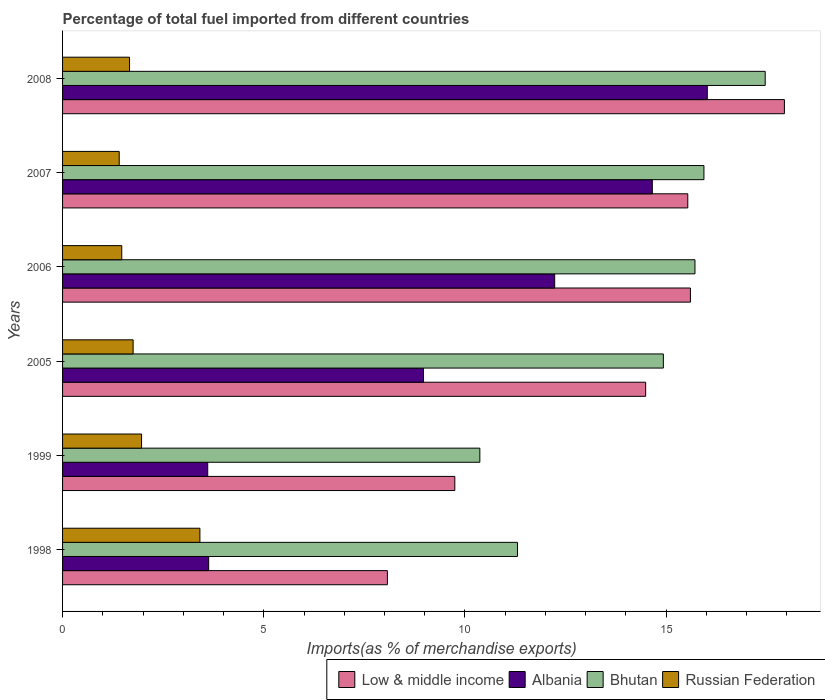How many different coloured bars are there?
Your response must be concise. 4. Are the number of bars per tick equal to the number of legend labels?
Ensure brevity in your answer.  Yes. How many bars are there on the 4th tick from the top?
Keep it short and to the point. 4. In how many cases, is the number of bars for a given year not equal to the number of legend labels?
Make the answer very short. 0. What is the percentage of imports to different countries in Russian Federation in 2005?
Keep it short and to the point. 1.75. Across all years, what is the maximum percentage of imports to different countries in Russian Federation?
Keep it short and to the point. 3.41. Across all years, what is the minimum percentage of imports to different countries in Low & middle income?
Offer a very short reply. 8.07. In which year was the percentage of imports to different countries in Albania minimum?
Your answer should be very brief. 1999. What is the total percentage of imports to different countries in Low & middle income in the graph?
Keep it short and to the point. 81.38. What is the difference between the percentage of imports to different countries in Russian Federation in 2007 and that in 2008?
Make the answer very short. -0.26. What is the difference between the percentage of imports to different countries in Russian Federation in 2006 and the percentage of imports to different countries in Albania in 2005?
Provide a succinct answer. -7.5. What is the average percentage of imports to different countries in Low & middle income per year?
Provide a short and direct response. 13.56. In the year 2006, what is the difference between the percentage of imports to different countries in Bhutan and percentage of imports to different countries in Albania?
Keep it short and to the point. 3.49. What is the ratio of the percentage of imports to different countries in Albania in 1999 to that in 2006?
Give a very brief answer. 0.29. Is the difference between the percentage of imports to different countries in Bhutan in 2005 and 2007 greater than the difference between the percentage of imports to different countries in Albania in 2005 and 2007?
Offer a very short reply. Yes. What is the difference between the highest and the second highest percentage of imports to different countries in Albania?
Provide a succinct answer. 1.37. What is the difference between the highest and the lowest percentage of imports to different countries in Low & middle income?
Your answer should be very brief. 9.87. In how many years, is the percentage of imports to different countries in Bhutan greater than the average percentage of imports to different countries in Bhutan taken over all years?
Offer a very short reply. 4. Is the sum of the percentage of imports to different countries in Bhutan in 1999 and 2006 greater than the maximum percentage of imports to different countries in Russian Federation across all years?
Make the answer very short. Yes. What does the 4th bar from the top in 2007 represents?
Ensure brevity in your answer.  Low & middle income. What does the 3rd bar from the bottom in 2005 represents?
Give a very brief answer. Bhutan. Is it the case that in every year, the sum of the percentage of imports to different countries in Bhutan and percentage of imports to different countries in Low & middle income is greater than the percentage of imports to different countries in Russian Federation?
Your answer should be compact. Yes. How many bars are there?
Ensure brevity in your answer.  24. Are all the bars in the graph horizontal?
Offer a very short reply. Yes. How many years are there in the graph?
Your response must be concise. 6. Are the values on the major ticks of X-axis written in scientific E-notation?
Ensure brevity in your answer.  No. Does the graph contain any zero values?
Keep it short and to the point. No. Where does the legend appear in the graph?
Provide a succinct answer. Bottom right. How many legend labels are there?
Offer a terse response. 4. What is the title of the graph?
Provide a succinct answer. Percentage of total fuel imported from different countries. What is the label or title of the X-axis?
Ensure brevity in your answer.  Imports(as % of merchandise exports). What is the Imports(as % of merchandise exports) of Low & middle income in 1998?
Offer a very short reply. 8.07. What is the Imports(as % of merchandise exports) of Albania in 1998?
Give a very brief answer. 3.63. What is the Imports(as % of merchandise exports) in Bhutan in 1998?
Your answer should be very brief. 11.3. What is the Imports(as % of merchandise exports) of Russian Federation in 1998?
Give a very brief answer. 3.41. What is the Imports(as % of merchandise exports) of Low & middle income in 1999?
Offer a terse response. 9.75. What is the Imports(as % of merchandise exports) in Albania in 1999?
Offer a very short reply. 3.61. What is the Imports(as % of merchandise exports) of Bhutan in 1999?
Provide a short and direct response. 10.37. What is the Imports(as % of merchandise exports) in Russian Federation in 1999?
Give a very brief answer. 1.96. What is the Imports(as % of merchandise exports) in Low & middle income in 2005?
Your response must be concise. 14.49. What is the Imports(as % of merchandise exports) in Albania in 2005?
Offer a very short reply. 8.97. What is the Imports(as % of merchandise exports) in Bhutan in 2005?
Offer a terse response. 14.93. What is the Imports(as % of merchandise exports) in Russian Federation in 2005?
Offer a very short reply. 1.75. What is the Imports(as % of merchandise exports) in Low & middle income in 2006?
Your answer should be compact. 15.6. What is the Imports(as % of merchandise exports) of Albania in 2006?
Give a very brief answer. 12.23. What is the Imports(as % of merchandise exports) of Bhutan in 2006?
Offer a very short reply. 15.71. What is the Imports(as % of merchandise exports) in Russian Federation in 2006?
Offer a very short reply. 1.47. What is the Imports(as % of merchandise exports) in Low & middle income in 2007?
Give a very brief answer. 15.54. What is the Imports(as % of merchandise exports) of Albania in 2007?
Offer a very short reply. 14.66. What is the Imports(as % of merchandise exports) in Bhutan in 2007?
Your response must be concise. 15.94. What is the Imports(as % of merchandise exports) in Russian Federation in 2007?
Your answer should be very brief. 1.41. What is the Imports(as % of merchandise exports) of Low & middle income in 2008?
Offer a terse response. 17.94. What is the Imports(as % of merchandise exports) of Albania in 2008?
Your response must be concise. 16.02. What is the Imports(as % of merchandise exports) in Bhutan in 2008?
Your answer should be compact. 17.46. What is the Imports(as % of merchandise exports) of Russian Federation in 2008?
Provide a short and direct response. 1.66. Across all years, what is the maximum Imports(as % of merchandise exports) in Low & middle income?
Offer a terse response. 17.94. Across all years, what is the maximum Imports(as % of merchandise exports) in Albania?
Your response must be concise. 16.02. Across all years, what is the maximum Imports(as % of merchandise exports) in Bhutan?
Offer a very short reply. 17.46. Across all years, what is the maximum Imports(as % of merchandise exports) of Russian Federation?
Provide a succinct answer. 3.41. Across all years, what is the minimum Imports(as % of merchandise exports) in Low & middle income?
Offer a very short reply. 8.07. Across all years, what is the minimum Imports(as % of merchandise exports) of Albania?
Keep it short and to the point. 3.61. Across all years, what is the minimum Imports(as % of merchandise exports) of Bhutan?
Offer a very short reply. 10.37. Across all years, what is the minimum Imports(as % of merchandise exports) in Russian Federation?
Ensure brevity in your answer.  1.41. What is the total Imports(as % of merchandise exports) in Low & middle income in the graph?
Make the answer very short. 81.38. What is the total Imports(as % of merchandise exports) of Albania in the graph?
Offer a very short reply. 59.11. What is the total Imports(as % of merchandise exports) in Bhutan in the graph?
Offer a very short reply. 85.72. What is the total Imports(as % of merchandise exports) in Russian Federation in the graph?
Provide a short and direct response. 11.67. What is the difference between the Imports(as % of merchandise exports) of Low & middle income in 1998 and that in 1999?
Ensure brevity in your answer.  -1.68. What is the difference between the Imports(as % of merchandise exports) of Albania in 1998 and that in 1999?
Provide a succinct answer. 0.02. What is the difference between the Imports(as % of merchandise exports) in Bhutan in 1998 and that in 1999?
Your answer should be very brief. 0.94. What is the difference between the Imports(as % of merchandise exports) in Russian Federation in 1998 and that in 1999?
Ensure brevity in your answer.  1.45. What is the difference between the Imports(as % of merchandise exports) of Low & middle income in 1998 and that in 2005?
Offer a terse response. -6.42. What is the difference between the Imports(as % of merchandise exports) in Albania in 1998 and that in 2005?
Ensure brevity in your answer.  -5.34. What is the difference between the Imports(as % of merchandise exports) in Bhutan in 1998 and that in 2005?
Offer a very short reply. -3.62. What is the difference between the Imports(as % of merchandise exports) of Russian Federation in 1998 and that in 2005?
Make the answer very short. 1.66. What is the difference between the Imports(as % of merchandise exports) of Low & middle income in 1998 and that in 2006?
Make the answer very short. -7.53. What is the difference between the Imports(as % of merchandise exports) in Albania in 1998 and that in 2006?
Provide a short and direct response. -8.6. What is the difference between the Imports(as % of merchandise exports) of Bhutan in 1998 and that in 2006?
Offer a terse response. -4.41. What is the difference between the Imports(as % of merchandise exports) in Russian Federation in 1998 and that in 2006?
Provide a short and direct response. 1.94. What is the difference between the Imports(as % of merchandise exports) of Low & middle income in 1998 and that in 2007?
Offer a terse response. -7.46. What is the difference between the Imports(as % of merchandise exports) in Albania in 1998 and that in 2007?
Offer a terse response. -11.02. What is the difference between the Imports(as % of merchandise exports) in Bhutan in 1998 and that in 2007?
Provide a succinct answer. -4.63. What is the difference between the Imports(as % of merchandise exports) of Russian Federation in 1998 and that in 2007?
Your answer should be compact. 2. What is the difference between the Imports(as % of merchandise exports) of Low & middle income in 1998 and that in 2008?
Provide a short and direct response. -9.87. What is the difference between the Imports(as % of merchandise exports) of Albania in 1998 and that in 2008?
Provide a short and direct response. -12.39. What is the difference between the Imports(as % of merchandise exports) in Bhutan in 1998 and that in 2008?
Provide a short and direct response. -6.16. What is the difference between the Imports(as % of merchandise exports) in Russian Federation in 1998 and that in 2008?
Your response must be concise. 1.75. What is the difference between the Imports(as % of merchandise exports) in Low & middle income in 1999 and that in 2005?
Your response must be concise. -4.74. What is the difference between the Imports(as % of merchandise exports) in Albania in 1999 and that in 2005?
Keep it short and to the point. -5.36. What is the difference between the Imports(as % of merchandise exports) of Bhutan in 1999 and that in 2005?
Your answer should be very brief. -4.56. What is the difference between the Imports(as % of merchandise exports) in Russian Federation in 1999 and that in 2005?
Offer a terse response. 0.21. What is the difference between the Imports(as % of merchandise exports) in Low & middle income in 1999 and that in 2006?
Your response must be concise. -5.85. What is the difference between the Imports(as % of merchandise exports) of Albania in 1999 and that in 2006?
Offer a terse response. -8.62. What is the difference between the Imports(as % of merchandise exports) in Bhutan in 1999 and that in 2006?
Provide a succinct answer. -5.35. What is the difference between the Imports(as % of merchandise exports) of Russian Federation in 1999 and that in 2006?
Give a very brief answer. 0.49. What is the difference between the Imports(as % of merchandise exports) of Low & middle income in 1999 and that in 2007?
Provide a short and direct response. -5.79. What is the difference between the Imports(as % of merchandise exports) in Albania in 1999 and that in 2007?
Your answer should be compact. -11.05. What is the difference between the Imports(as % of merchandise exports) of Bhutan in 1999 and that in 2007?
Offer a terse response. -5.57. What is the difference between the Imports(as % of merchandise exports) in Russian Federation in 1999 and that in 2007?
Offer a terse response. 0.56. What is the difference between the Imports(as % of merchandise exports) in Low & middle income in 1999 and that in 2008?
Offer a very short reply. -8.19. What is the difference between the Imports(as % of merchandise exports) of Albania in 1999 and that in 2008?
Give a very brief answer. -12.41. What is the difference between the Imports(as % of merchandise exports) in Bhutan in 1999 and that in 2008?
Provide a short and direct response. -7.09. What is the difference between the Imports(as % of merchandise exports) of Russian Federation in 1999 and that in 2008?
Make the answer very short. 0.3. What is the difference between the Imports(as % of merchandise exports) of Low & middle income in 2005 and that in 2006?
Give a very brief answer. -1.11. What is the difference between the Imports(as % of merchandise exports) of Albania in 2005 and that in 2006?
Keep it short and to the point. -3.26. What is the difference between the Imports(as % of merchandise exports) of Bhutan in 2005 and that in 2006?
Ensure brevity in your answer.  -0.79. What is the difference between the Imports(as % of merchandise exports) of Russian Federation in 2005 and that in 2006?
Make the answer very short. 0.28. What is the difference between the Imports(as % of merchandise exports) in Low & middle income in 2005 and that in 2007?
Make the answer very short. -1.05. What is the difference between the Imports(as % of merchandise exports) in Albania in 2005 and that in 2007?
Keep it short and to the point. -5.69. What is the difference between the Imports(as % of merchandise exports) in Bhutan in 2005 and that in 2007?
Offer a terse response. -1.01. What is the difference between the Imports(as % of merchandise exports) of Russian Federation in 2005 and that in 2007?
Provide a succinct answer. 0.35. What is the difference between the Imports(as % of merchandise exports) in Low & middle income in 2005 and that in 2008?
Provide a short and direct response. -3.45. What is the difference between the Imports(as % of merchandise exports) in Albania in 2005 and that in 2008?
Make the answer very short. -7.05. What is the difference between the Imports(as % of merchandise exports) in Bhutan in 2005 and that in 2008?
Keep it short and to the point. -2.53. What is the difference between the Imports(as % of merchandise exports) in Russian Federation in 2005 and that in 2008?
Your response must be concise. 0.09. What is the difference between the Imports(as % of merchandise exports) in Low & middle income in 2006 and that in 2007?
Keep it short and to the point. 0.07. What is the difference between the Imports(as % of merchandise exports) of Albania in 2006 and that in 2007?
Give a very brief answer. -2.43. What is the difference between the Imports(as % of merchandise exports) in Bhutan in 2006 and that in 2007?
Your response must be concise. -0.22. What is the difference between the Imports(as % of merchandise exports) in Russian Federation in 2006 and that in 2007?
Make the answer very short. 0.06. What is the difference between the Imports(as % of merchandise exports) of Low & middle income in 2006 and that in 2008?
Offer a very short reply. -2.34. What is the difference between the Imports(as % of merchandise exports) in Albania in 2006 and that in 2008?
Your answer should be compact. -3.79. What is the difference between the Imports(as % of merchandise exports) in Bhutan in 2006 and that in 2008?
Provide a short and direct response. -1.75. What is the difference between the Imports(as % of merchandise exports) in Russian Federation in 2006 and that in 2008?
Ensure brevity in your answer.  -0.19. What is the difference between the Imports(as % of merchandise exports) in Low & middle income in 2007 and that in 2008?
Offer a very short reply. -2.4. What is the difference between the Imports(as % of merchandise exports) of Albania in 2007 and that in 2008?
Give a very brief answer. -1.37. What is the difference between the Imports(as % of merchandise exports) in Bhutan in 2007 and that in 2008?
Give a very brief answer. -1.52. What is the difference between the Imports(as % of merchandise exports) of Russian Federation in 2007 and that in 2008?
Your response must be concise. -0.26. What is the difference between the Imports(as % of merchandise exports) of Low & middle income in 1998 and the Imports(as % of merchandise exports) of Albania in 1999?
Keep it short and to the point. 4.46. What is the difference between the Imports(as % of merchandise exports) of Low & middle income in 1998 and the Imports(as % of merchandise exports) of Bhutan in 1999?
Offer a very short reply. -2.3. What is the difference between the Imports(as % of merchandise exports) in Low & middle income in 1998 and the Imports(as % of merchandise exports) in Russian Federation in 1999?
Ensure brevity in your answer.  6.11. What is the difference between the Imports(as % of merchandise exports) in Albania in 1998 and the Imports(as % of merchandise exports) in Bhutan in 1999?
Provide a succinct answer. -6.74. What is the difference between the Imports(as % of merchandise exports) in Albania in 1998 and the Imports(as % of merchandise exports) in Russian Federation in 1999?
Keep it short and to the point. 1.67. What is the difference between the Imports(as % of merchandise exports) in Bhutan in 1998 and the Imports(as % of merchandise exports) in Russian Federation in 1999?
Offer a very short reply. 9.34. What is the difference between the Imports(as % of merchandise exports) of Low & middle income in 1998 and the Imports(as % of merchandise exports) of Albania in 2005?
Give a very brief answer. -0.9. What is the difference between the Imports(as % of merchandise exports) in Low & middle income in 1998 and the Imports(as % of merchandise exports) in Bhutan in 2005?
Ensure brevity in your answer.  -6.86. What is the difference between the Imports(as % of merchandise exports) in Low & middle income in 1998 and the Imports(as % of merchandise exports) in Russian Federation in 2005?
Keep it short and to the point. 6.32. What is the difference between the Imports(as % of merchandise exports) of Albania in 1998 and the Imports(as % of merchandise exports) of Bhutan in 2005?
Provide a short and direct response. -11.3. What is the difference between the Imports(as % of merchandise exports) of Albania in 1998 and the Imports(as % of merchandise exports) of Russian Federation in 2005?
Your answer should be compact. 1.88. What is the difference between the Imports(as % of merchandise exports) in Bhutan in 1998 and the Imports(as % of merchandise exports) in Russian Federation in 2005?
Ensure brevity in your answer.  9.55. What is the difference between the Imports(as % of merchandise exports) of Low & middle income in 1998 and the Imports(as % of merchandise exports) of Albania in 2006?
Give a very brief answer. -4.16. What is the difference between the Imports(as % of merchandise exports) of Low & middle income in 1998 and the Imports(as % of merchandise exports) of Bhutan in 2006?
Make the answer very short. -7.64. What is the difference between the Imports(as % of merchandise exports) in Low & middle income in 1998 and the Imports(as % of merchandise exports) in Russian Federation in 2006?
Offer a terse response. 6.6. What is the difference between the Imports(as % of merchandise exports) of Albania in 1998 and the Imports(as % of merchandise exports) of Bhutan in 2006?
Offer a very short reply. -12.08. What is the difference between the Imports(as % of merchandise exports) of Albania in 1998 and the Imports(as % of merchandise exports) of Russian Federation in 2006?
Offer a very short reply. 2.16. What is the difference between the Imports(as % of merchandise exports) in Bhutan in 1998 and the Imports(as % of merchandise exports) in Russian Federation in 2006?
Your answer should be very brief. 9.83. What is the difference between the Imports(as % of merchandise exports) in Low & middle income in 1998 and the Imports(as % of merchandise exports) in Albania in 2007?
Ensure brevity in your answer.  -6.58. What is the difference between the Imports(as % of merchandise exports) of Low & middle income in 1998 and the Imports(as % of merchandise exports) of Bhutan in 2007?
Ensure brevity in your answer.  -7.87. What is the difference between the Imports(as % of merchandise exports) in Low & middle income in 1998 and the Imports(as % of merchandise exports) in Russian Federation in 2007?
Keep it short and to the point. 6.66. What is the difference between the Imports(as % of merchandise exports) of Albania in 1998 and the Imports(as % of merchandise exports) of Bhutan in 2007?
Give a very brief answer. -12.31. What is the difference between the Imports(as % of merchandise exports) of Albania in 1998 and the Imports(as % of merchandise exports) of Russian Federation in 2007?
Keep it short and to the point. 2.22. What is the difference between the Imports(as % of merchandise exports) in Bhutan in 1998 and the Imports(as % of merchandise exports) in Russian Federation in 2007?
Offer a very short reply. 9.9. What is the difference between the Imports(as % of merchandise exports) of Low & middle income in 1998 and the Imports(as % of merchandise exports) of Albania in 2008?
Provide a succinct answer. -7.95. What is the difference between the Imports(as % of merchandise exports) of Low & middle income in 1998 and the Imports(as % of merchandise exports) of Bhutan in 2008?
Your answer should be very brief. -9.39. What is the difference between the Imports(as % of merchandise exports) in Low & middle income in 1998 and the Imports(as % of merchandise exports) in Russian Federation in 2008?
Offer a very short reply. 6.41. What is the difference between the Imports(as % of merchandise exports) in Albania in 1998 and the Imports(as % of merchandise exports) in Bhutan in 2008?
Offer a terse response. -13.83. What is the difference between the Imports(as % of merchandise exports) in Albania in 1998 and the Imports(as % of merchandise exports) in Russian Federation in 2008?
Provide a succinct answer. 1.97. What is the difference between the Imports(as % of merchandise exports) of Bhutan in 1998 and the Imports(as % of merchandise exports) of Russian Federation in 2008?
Make the answer very short. 9.64. What is the difference between the Imports(as % of merchandise exports) in Low & middle income in 1999 and the Imports(as % of merchandise exports) in Albania in 2005?
Keep it short and to the point. 0.78. What is the difference between the Imports(as % of merchandise exports) in Low & middle income in 1999 and the Imports(as % of merchandise exports) in Bhutan in 2005?
Your answer should be very brief. -5.18. What is the difference between the Imports(as % of merchandise exports) in Low & middle income in 1999 and the Imports(as % of merchandise exports) in Russian Federation in 2005?
Your response must be concise. 7.99. What is the difference between the Imports(as % of merchandise exports) in Albania in 1999 and the Imports(as % of merchandise exports) in Bhutan in 2005?
Offer a very short reply. -11.32. What is the difference between the Imports(as % of merchandise exports) of Albania in 1999 and the Imports(as % of merchandise exports) of Russian Federation in 2005?
Make the answer very short. 1.85. What is the difference between the Imports(as % of merchandise exports) of Bhutan in 1999 and the Imports(as % of merchandise exports) of Russian Federation in 2005?
Keep it short and to the point. 8.62. What is the difference between the Imports(as % of merchandise exports) in Low & middle income in 1999 and the Imports(as % of merchandise exports) in Albania in 2006?
Your response must be concise. -2.48. What is the difference between the Imports(as % of merchandise exports) in Low & middle income in 1999 and the Imports(as % of merchandise exports) in Bhutan in 2006?
Provide a succinct answer. -5.97. What is the difference between the Imports(as % of merchandise exports) in Low & middle income in 1999 and the Imports(as % of merchandise exports) in Russian Federation in 2006?
Your answer should be very brief. 8.28. What is the difference between the Imports(as % of merchandise exports) in Albania in 1999 and the Imports(as % of merchandise exports) in Bhutan in 2006?
Provide a succinct answer. -12.11. What is the difference between the Imports(as % of merchandise exports) of Albania in 1999 and the Imports(as % of merchandise exports) of Russian Federation in 2006?
Provide a succinct answer. 2.14. What is the difference between the Imports(as % of merchandise exports) of Bhutan in 1999 and the Imports(as % of merchandise exports) of Russian Federation in 2006?
Offer a very short reply. 8.9. What is the difference between the Imports(as % of merchandise exports) of Low & middle income in 1999 and the Imports(as % of merchandise exports) of Albania in 2007?
Keep it short and to the point. -4.91. What is the difference between the Imports(as % of merchandise exports) of Low & middle income in 1999 and the Imports(as % of merchandise exports) of Bhutan in 2007?
Your response must be concise. -6.19. What is the difference between the Imports(as % of merchandise exports) of Low & middle income in 1999 and the Imports(as % of merchandise exports) of Russian Federation in 2007?
Keep it short and to the point. 8.34. What is the difference between the Imports(as % of merchandise exports) in Albania in 1999 and the Imports(as % of merchandise exports) in Bhutan in 2007?
Give a very brief answer. -12.33. What is the difference between the Imports(as % of merchandise exports) of Albania in 1999 and the Imports(as % of merchandise exports) of Russian Federation in 2007?
Provide a succinct answer. 2.2. What is the difference between the Imports(as % of merchandise exports) of Bhutan in 1999 and the Imports(as % of merchandise exports) of Russian Federation in 2007?
Your answer should be very brief. 8.96. What is the difference between the Imports(as % of merchandise exports) in Low & middle income in 1999 and the Imports(as % of merchandise exports) in Albania in 2008?
Offer a very short reply. -6.27. What is the difference between the Imports(as % of merchandise exports) in Low & middle income in 1999 and the Imports(as % of merchandise exports) in Bhutan in 2008?
Make the answer very short. -7.71. What is the difference between the Imports(as % of merchandise exports) in Low & middle income in 1999 and the Imports(as % of merchandise exports) in Russian Federation in 2008?
Provide a succinct answer. 8.08. What is the difference between the Imports(as % of merchandise exports) in Albania in 1999 and the Imports(as % of merchandise exports) in Bhutan in 2008?
Offer a very short reply. -13.85. What is the difference between the Imports(as % of merchandise exports) of Albania in 1999 and the Imports(as % of merchandise exports) of Russian Federation in 2008?
Your answer should be very brief. 1.94. What is the difference between the Imports(as % of merchandise exports) in Bhutan in 1999 and the Imports(as % of merchandise exports) in Russian Federation in 2008?
Keep it short and to the point. 8.7. What is the difference between the Imports(as % of merchandise exports) of Low & middle income in 2005 and the Imports(as % of merchandise exports) of Albania in 2006?
Your response must be concise. 2.26. What is the difference between the Imports(as % of merchandise exports) in Low & middle income in 2005 and the Imports(as % of merchandise exports) in Bhutan in 2006?
Offer a very short reply. -1.22. What is the difference between the Imports(as % of merchandise exports) of Low & middle income in 2005 and the Imports(as % of merchandise exports) of Russian Federation in 2006?
Give a very brief answer. 13.02. What is the difference between the Imports(as % of merchandise exports) in Albania in 2005 and the Imports(as % of merchandise exports) in Bhutan in 2006?
Your response must be concise. -6.75. What is the difference between the Imports(as % of merchandise exports) in Albania in 2005 and the Imports(as % of merchandise exports) in Russian Federation in 2006?
Ensure brevity in your answer.  7.5. What is the difference between the Imports(as % of merchandise exports) of Bhutan in 2005 and the Imports(as % of merchandise exports) of Russian Federation in 2006?
Ensure brevity in your answer.  13.46. What is the difference between the Imports(as % of merchandise exports) of Low & middle income in 2005 and the Imports(as % of merchandise exports) of Albania in 2007?
Your response must be concise. -0.17. What is the difference between the Imports(as % of merchandise exports) of Low & middle income in 2005 and the Imports(as % of merchandise exports) of Bhutan in 2007?
Provide a short and direct response. -1.45. What is the difference between the Imports(as % of merchandise exports) in Low & middle income in 2005 and the Imports(as % of merchandise exports) in Russian Federation in 2007?
Offer a very short reply. 13.08. What is the difference between the Imports(as % of merchandise exports) of Albania in 2005 and the Imports(as % of merchandise exports) of Bhutan in 2007?
Ensure brevity in your answer.  -6.97. What is the difference between the Imports(as % of merchandise exports) in Albania in 2005 and the Imports(as % of merchandise exports) in Russian Federation in 2007?
Provide a short and direct response. 7.56. What is the difference between the Imports(as % of merchandise exports) in Bhutan in 2005 and the Imports(as % of merchandise exports) in Russian Federation in 2007?
Provide a short and direct response. 13.52. What is the difference between the Imports(as % of merchandise exports) in Low & middle income in 2005 and the Imports(as % of merchandise exports) in Albania in 2008?
Provide a succinct answer. -1.53. What is the difference between the Imports(as % of merchandise exports) of Low & middle income in 2005 and the Imports(as % of merchandise exports) of Bhutan in 2008?
Ensure brevity in your answer.  -2.97. What is the difference between the Imports(as % of merchandise exports) of Low & middle income in 2005 and the Imports(as % of merchandise exports) of Russian Federation in 2008?
Give a very brief answer. 12.83. What is the difference between the Imports(as % of merchandise exports) in Albania in 2005 and the Imports(as % of merchandise exports) in Bhutan in 2008?
Your answer should be compact. -8.49. What is the difference between the Imports(as % of merchandise exports) of Albania in 2005 and the Imports(as % of merchandise exports) of Russian Federation in 2008?
Your answer should be very brief. 7.3. What is the difference between the Imports(as % of merchandise exports) in Bhutan in 2005 and the Imports(as % of merchandise exports) in Russian Federation in 2008?
Keep it short and to the point. 13.27. What is the difference between the Imports(as % of merchandise exports) in Low & middle income in 2006 and the Imports(as % of merchandise exports) in Albania in 2007?
Your response must be concise. 0.95. What is the difference between the Imports(as % of merchandise exports) in Low & middle income in 2006 and the Imports(as % of merchandise exports) in Bhutan in 2007?
Your answer should be compact. -0.34. What is the difference between the Imports(as % of merchandise exports) of Low & middle income in 2006 and the Imports(as % of merchandise exports) of Russian Federation in 2007?
Provide a short and direct response. 14.19. What is the difference between the Imports(as % of merchandise exports) in Albania in 2006 and the Imports(as % of merchandise exports) in Bhutan in 2007?
Make the answer very short. -3.71. What is the difference between the Imports(as % of merchandise exports) of Albania in 2006 and the Imports(as % of merchandise exports) of Russian Federation in 2007?
Keep it short and to the point. 10.82. What is the difference between the Imports(as % of merchandise exports) in Bhutan in 2006 and the Imports(as % of merchandise exports) in Russian Federation in 2007?
Offer a terse response. 14.31. What is the difference between the Imports(as % of merchandise exports) in Low & middle income in 2006 and the Imports(as % of merchandise exports) in Albania in 2008?
Give a very brief answer. -0.42. What is the difference between the Imports(as % of merchandise exports) in Low & middle income in 2006 and the Imports(as % of merchandise exports) in Bhutan in 2008?
Your answer should be very brief. -1.86. What is the difference between the Imports(as % of merchandise exports) in Low & middle income in 2006 and the Imports(as % of merchandise exports) in Russian Federation in 2008?
Offer a very short reply. 13.94. What is the difference between the Imports(as % of merchandise exports) of Albania in 2006 and the Imports(as % of merchandise exports) of Bhutan in 2008?
Offer a very short reply. -5.23. What is the difference between the Imports(as % of merchandise exports) in Albania in 2006 and the Imports(as % of merchandise exports) in Russian Federation in 2008?
Make the answer very short. 10.56. What is the difference between the Imports(as % of merchandise exports) in Bhutan in 2006 and the Imports(as % of merchandise exports) in Russian Federation in 2008?
Provide a succinct answer. 14.05. What is the difference between the Imports(as % of merchandise exports) of Low & middle income in 2007 and the Imports(as % of merchandise exports) of Albania in 2008?
Your response must be concise. -0.48. What is the difference between the Imports(as % of merchandise exports) in Low & middle income in 2007 and the Imports(as % of merchandise exports) in Bhutan in 2008?
Your response must be concise. -1.92. What is the difference between the Imports(as % of merchandise exports) of Low & middle income in 2007 and the Imports(as % of merchandise exports) of Russian Federation in 2008?
Your answer should be compact. 13.87. What is the difference between the Imports(as % of merchandise exports) in Albania in 2007 and the Imports(as % of merchandise exports) in Bhutan in 2008?
Provide a succinct answer. -2.81. What is the difference between the Imports(as % of merchandise exports) in Albania in 2007 and the Imports(as % of merchandise exports) in Russian Federation in 2008?
Ensure brevity in your answer.  12.99. What is the difference between the Imports(as % of merchandise exports) of Bhutan in 2007 and the Imports(as % of merchandise exports) of Russian Federation in 2008?
Offer a very short reply. 14.27. What is the average Imports(as % of merchandise exports) of Low & middle income per year?
Ensure brevity in your answer.  13.56. What is the average Imports(as % of merchandise exports) of Albania per year?
Offer a terse response. 9.85. What is the average Imports(as % of merchandise exports) in Bhutan per year?
Provide a succinct answer. 14.29. What is the average Imports(as % of merchandise exports) of Russian Federation per year?
Your answer should be compact. 1.95. In the year 1998, what is the difference between the Imports(as % of merchandise exports) in Low & middle income and Imports(as % of merchandise exports) in Albania?
Make the answer very short. 4.44. In the year 1998, what is the difference between the Imports(as % of merchandise exports) in Low & middle income and Imports(as % of merchandise exports) in Bhutan?
Offer a very short reply. -3.23. In the year 1998, what is the difference between the Imports(as % of merchandise exports) of Low & middle income and Imports(as % of merchandise exports) of Russian Federation?
Offer a terse response. 4.66. In the year 1998, what is the difference between the Imports(as % of merchandise exports) of Albania and Imports(as % of merchandise exports) of Bhutan?
Provide a succinct answer. -7.67. In the year 1998, what is the difference between the Imports(as % of merchandise exports) in Albania and Imports(as % of merchandise exports) in Russian Federation?
Offer a very short reply. 0.22. In the year 1998, what is the difference between the Imports(as % of merchandise exports) in Bhutan and Imports(as % of merchandise exports) in Russian Federation?
Provide a succinct answer. 7.89. In the year 1999, what is the difference between the Imports(as % of merchandise exports) of Low & middle income and Imports(as % of merchandise exports) of Albania?
Your answer should be very brief. 6.14. In the year 1999, what is the difference between the Imports(as % of merchandise exports) of Low & middle income and Imports(as % of merchandise exports) of Bhutan?
Your response must be concise. -0.62. In the year 1999, what is the difference between the Imports(as % of merchandise exports) of Low & middle income and Imports(as % of merchandise exports) of Russian Federation?
Your answer should be very brief. 7.78. In the year 1999, what is the difference between the Imports(as % of merchandise exports) of Albania and Imports(as % of merchandise exports) of Bhutan?
Your answer should be very brief. -6.76. In the year 1999, what is the difference between the Imports(as % of merchandise exports) in Albania and Imports(as % of merchandise exports) in Russian Federation?
Your answer should be very brief. 1.64. In the year 1999, what is the difference between the Imports(as % of merchandise exports) in Bhutan and Imports(as % of merchandise exports) in Russian Federation?
Provide a short and direct response. 8.41. In the year 2005, what is the difference between the Imports(as % of merchandise exports) of Low & middle income and Imports(as % of merchandise exports) of Albania?
Your answer should be very brief. 5.52. In the year 2005, what is the difference between the Imports(as % of merchandise exports) in Low & middle income and Imports(as % of merchandise exports) in Bhutan?
Offer a terse response. -0.44. In the year 2005, what is the difference between the Imports(as % of merchandise exports) in Low & middle income and Imports(as % of merchandise exports) in Russian Federation?
Your answer should be very brief. 12.74. In the year 2005, what is the difference between the Imports(as % of merchandise exports) in Albania and Imports(as % of merchandise exports) in Bhutan?
Ensure brevity in your answer.  -5.96. In the year 2005, what is the difference between the Imports(as % of merchandise exports) in Albania and Imports(as % of merchandise exports) in Russian Federation?
Offer a very short reply. 7.22. In the year 2005, what is the difference between the Imports(as % of merchandise exports) of Bhutan and Imports(as % of merchandise exports) of Russian Federation?
Your response must be concise. 13.18. In the year 2006, what is the difference between the Imports(as % of merchandise exports) in Low & middle income and Imports(as % of merchandise exports) in Albania?
Keep it short and to the point. 3.37. In the year 2006, what is the difference between the Imports(as % of merchandise exports) of Low & middle income and Imports(as % of merchandise exports) of Bhutan?
Ensure brevity in your answer.  -0.11. In the year 2006, what is the difference between the Imports(as % of merchandise exports) of Low & middle income and Imports(as % of merchandise exports) of Russian Federation?
Your answer should be very brief. 14.13. In the year 2006, what is the difference between the Imports(as % of merchandise exports) of Albania and Imports(as % of merchandise exports) of Bhutan?
Offer a very short reply. -3.49. In the year 2006, what is the difference between the Imports(as % of merchandise exports) of Albania and Imports(as % of merchandise exports) of Russian Federation?
Keep it short and to the point. 10.76. In the year 2006, what is the difference between the Imports(as % of merchandise exports) of Bhutan and Imports(as % of merchandise exports) of Russian Federation?
Offer a terse response. 14.24. In the year 2007, what is the difference between the Imports(as % of merchandise exports) of Low & middle income and Imports(as % of merchandise exports) of Albania?
Make the answer very short. 0.88. In the year 2007, what is the difference between the Imports(as % of merchandise exports) of Low & middle income and Imports(as % of merchandise exports) of Bhutan?
Ensure brevity in your answer.  -0.4. In the year 2007, what is the difference between the Imports(as % of merchandise exports) of Low & middle income and Imports(as % of merchandise exports) of Russian Federation?
Give a very brief answer. 14.13. In the year 2007, what is the difference between the Imports(as % of merchandise exports) in Albania and Imports(as % of merchandise exports) in Bhutan?
Keep it short and to the point. -1.28. In the year 2007, what is the difference between the Imports(as % of merchandise exports) in Albania and Imports(as % of merchandise exports) in Russian Federation?
Make the answer very short. 13.25. In the year 2007, what is the difference between the Imports(as % of merchandise exports) in Bhutan and Imports(as % of merchandise exports) in Russian Federation?
Provide a succinct answer. 14.53. In the year 2008, what is the difference between the Imports(as % of merchandise exports) of Low & middle income and Imports(as % of merchandise exports) of Albania?
Give a very brief answer. 1.92. In the year 2008, what is the difference between the Imports(as % of merchandise exports) in Low & middle income and Imports(as % of merchandise exports) in Bhutan?
Provide a short and direct response. 0.48. In the year 2008, what is the difference between the Imports(as % of merchandise exports) in Low & middle income and Imports(as % of merchandise exports) in Russian Federation?
Ensure brevity in your answer.  16.27. In the year 2008, what is the difference between the Imports(as % of merchandise exports) in Albania and Imports(as % of merchandise exports) in Bhutan?
Make the answer very short. -1.44. In the year 2008, what is the difference between the Imports(as % of merchandise exports) of Albania and Imports(as % of merchandise exports) of Russian Federation?
Offer a very short reply. 14.36. In the year 2008, what is the difference between the Imports(as % of merchandise exports) in Bhutan and Imports(as % of merchandise exports) in Russian Federation?
Offer a very short reply. 15.8. What is the ratio of the Imports(as % of merchandise exports) in Low & middle income in 1998 to that in 1999?
Your answer should be very brief. 0.83. What is the ratio of the Imports(as % of merchandise exports) of Bhutan in 1998 to that in 1999?
Your answer should be compact. 1.09. What is the ratio of the Imports(as % of merchandise exports) in Russian Federation in 1998 to that in 1999?
Your answer should be compact. 1.74. What is the ratio of the Imports(as % of merchandise exports) of Low & middle income in 1998 to that in 2005?
Give a very brief answer. 0.56. What is the ratio of the Imports(as % of merchandise exports) of Albania in 1998 to that in 2005?
Offer a very short reply. 0.4. What is the ratio of the Imports(as % of merchandise exports) of Bhutan in 1998 to that in 2005?
Offer a terse response. 0.76. What is the ratio of the Imports(as % of merchandise exports) in Russian Federation in 1998 to that in 2005?
Offer a very short reply. 1.95. What is the ratio of the Imports(as % of merchandise exports) in Low & middle income in 1998 to that in 2006?
Make the answer very short. 0.52. What is the ratio of the Imports(as % of merchandise exports) of Albania in 1998 to that in 2006?
Offer a terse response. 0.3. What is the ratio of the Imports(as % of merchandise exports) of Bhutan in 1998 to that in 2006?
Keep it short and to the point. 0.72. What is the ratio of the Imports(as % of merchandise exports) of Russian Federation in 1998 to that in 2006?
Make the answer very short. 2.32. What is the ratio of the Imports(as % of merchandise exports) of Low & middle income in 1998 to that in 2007?
Offer a very short reply. 0.52. What is the ratio of the Imports(as % of merchandise exports) of Albania in 1998 to that in 2007?
Make the answer very short. 0.25. What is the ratio of the Imports(as % of merchandise exports) in Bhutan in 1998 to that in 2007?
Provide a succinct answer. 0.71. What is the ratio of the Imports(as % of merchandise exports) in Russian Federation in 1998 to that in 2007?
Provide a short and direct response. 2.42. What is the ratio of the Imports(as % of merchandise exports) of Low & middle income in 1998 to that in 2008?
Your answer should be compact. 0.45. What is the ratio of the Imports(as % of merchandise exports) of Albania in 1998 to that in 2008?
Offer a terse response. 0.23. What is the ratio of the Imports(as % of merchandise exports) of Bhutan in 1998 to that in 2008?
Ensure brevity in your answer.  0.65. What is the ratio of the Imports(as % of merchandise exports) of Russian Federation in 1998 to that in 2008?
Offer a very short reply. 2.05. What is the ratio of the Imports(as % of merchandise exports) in Low & middle income in 1999 to that in 2005?
Offer a very short reply. 0.67. What is the ratio of the Imports(as % of merchandise exports) of Albania in 1999 to that in 2005?
Offer a very short reply. 0.4. What is the ratio of the Imports(as % of merchandise exports) in Bhutan in 1999 to that in 2005?
Your response must be concise. 0.69. What is the ratio of the Imports(as % of merchandise exports) of Russian Federation in 1999 to that in 2005?
Keep it short and to the point. 1.12. What is the ratio of the Imports(as % of merchandise exports) in Low & middle income in 1999 to that in 2006?
Make the answer very short. 0.62. What is the ratio of the Imports(as % of merchandise exports) in Albania in 1999 to that in 2006?
Provide a short and direct response. 0.29. What is the ratio of the Imports(as % of merchandise exports) in Bhutan in 1999 to that in 2006?
Ensure brevity in your answer.  0.66. What is the ratio of the Imports(as % of merchandise exports) of Russian Federation in 1999 to that in 2006?
Your answer should be very brief. 1.33. What is the ratio of the Imports(as % of merchandise exports) in Low & middle income in 1999 to that in 2007?
Your answer should be very brief. 0.63. What is the ratio of the Imports(as % of merchandise exports) of Albania in 1999 to that in 2007?
Your answer should be very brief. 0.25. What is the ratio of the Imports(as % of merchandise exports) in Bhutan in 1999 to that in 2007?
Provide a short and direct response. 0.65. What is the ratio of the Imports(as % of merchandise exports) in Russian Federation in 1999 to that in 2007?
Offer a terse response. 1.39. What is the ratio of the Imports(as % of merchandise exports) in Low & middle income in 1999 to that in 2008?
Your response must be concise. 0.54. What is the ratio of the Imports(as % of merchandise exports) of Albania in 1999 to that in 2008?
Keep it short and to the point. 0.23. What is the ratio of the Imports(as % of merchandise exports) of Bhutan in 1999 to that in 2008?
Provide a short and direct response. 0.59. What is the ratio of the Imports(as % of merchandise exports) in Russian Federation in 1999 to that in 2008?
Offer a very short reply. 1.18. What is the ratio of the Imports(as % of merchandise exports) of Low & middle income in 2005 to that in 2006?
Your response must be concise. 0.93. What is the ratio of the Imports(as % of merchandise exports) of Albania in 2005 to that in 2006?
Give a very brief answer. 0.73. What is the ratio of the Imports(as % of merchandise exports) of Bhutan in 2005 to that in 2006?
Your answer should be compact. 0.95. What is the ratio of the Imports(as % of merchandise exports) in Russian Federation in 2005 to that in 2006?
Provide a succinct answer. 1.19. What is the ratio of the Imports(as % of merchandise exports) in Low & middle income in 2005 to that in 2007?
Provide a short and direct response. 0.93. What is the ratio of the Imports(as % of merchandise exports) of Albania in 2005 to that in 2007?
Ensure brevity in your answer.  0.61. What is the ratio of the Imports(as % of merchandise exports) in Bhutan in 2005 to that in 2007?
Keep it short and to the point. 0.94. What is the ratio of the Imports(as % of merchandise exports) of Russian Federation in 2005 to that in 2007?
Your response must be concise. 1.25. What is the ratio of the Imports(as % of merchandise exports) in Low & middle income in 2005 to that in 2008?
Provide a short and direct response. 0.81. What is the ratio of the Imports(as % of merchandise exports) in Albania in 2005 to that in 2008?
Your answer should be very brief. 0.56. What is the ratio of the Imports(as % of merchandise exports) of Bhutan in 2005 to that in 2008?
Ensure brevity in your answer.  0.86. What is the ratio of the Imports(as % of merchandise exports) of Russian Federation in 2005 to that in 2008?
Keep it short and to the point. 1.05. What is the ratio of the Imports(as % of merchandise exports) in Low & middle income in 2006 to that in 2007?
Provide a short and direct response. 1. What is the ratio of the Imports(as % of merchandise exports) of Albania in 2006 to that in 2007?
Provide a succinct answer. 0.83. What is the ratio of the Imports(as % of merchandise exports) in Russian Federation in 2006 to that in 2007?
Offer a very short reply. 1.04. What is the ratio of the Imports(as % of merchandise exports) of Low & middle income in 2006 to that in 2008?
Provide a succinct answer. 0.87. What is the ratio of the Imports(as % of merchandise exports) of Albania in 2006 to that in 2008?
Your response must be concise. 0.76. What is the ratio of the Imports(as % of merchandise exports) of Russian Federation in 2006 to that in 2008?
Offer a terse response. 0.88. What is the ratio of the Imports(as % of merchandise exports) of Low & middle income in 2007 to that in 2008?
Keep it short and to the point. 0.87. What is the ratio of the Imports(as % of merchandise exports) in Albania in 2007 to that in 2008?
Ensure brevity in your answer.  0.91. What is the ratio of the Imports(as % of merchandise exports) in Bhutan in 2007 to that in 2008?
Make the answer very short. 0.91. What is the ratio of the Imports(as % of merchandise exports) in Russian Federation in 2007 to that in 2008?
Offer a terse response. 0.85. What is the difference between the highest and the second highest Imports(as % of merchandise exports) of Low & middle income?
Offer a terse response. 2.34. What is the difference between the highest and the second highest Imports(as % of merchandise exports) of Albania?
Offer a terse response. 1.37. What is the difference between the highest and the second highest Imports(as % of merchandise exports) of Bhutan?
Provide a short and direct response. 1.52. What is the difference between the highest and the second highest Imports(as % of merchandise exports) of Russian Federation?
Keep it short and to the point. 1.45. What is the difference between the highest and the lowest Imports(as % of merchandise exports) of Low & middle income?
Your answer should be compact. 9.87. What is the difference between the highest and the lowest Imports(as % of merchandise exports) of Albania?
Offer a very short reply. 12.41. What is the difference between the highest and the lowest Imports(as % of merchandise exports) of Bhutan?
Provide a short and direct response. 7.09. What is the difference between the highest and the lowest Imports(as % of merchandise exports) of Russian Federation?
Give a very brief answer. 2. 